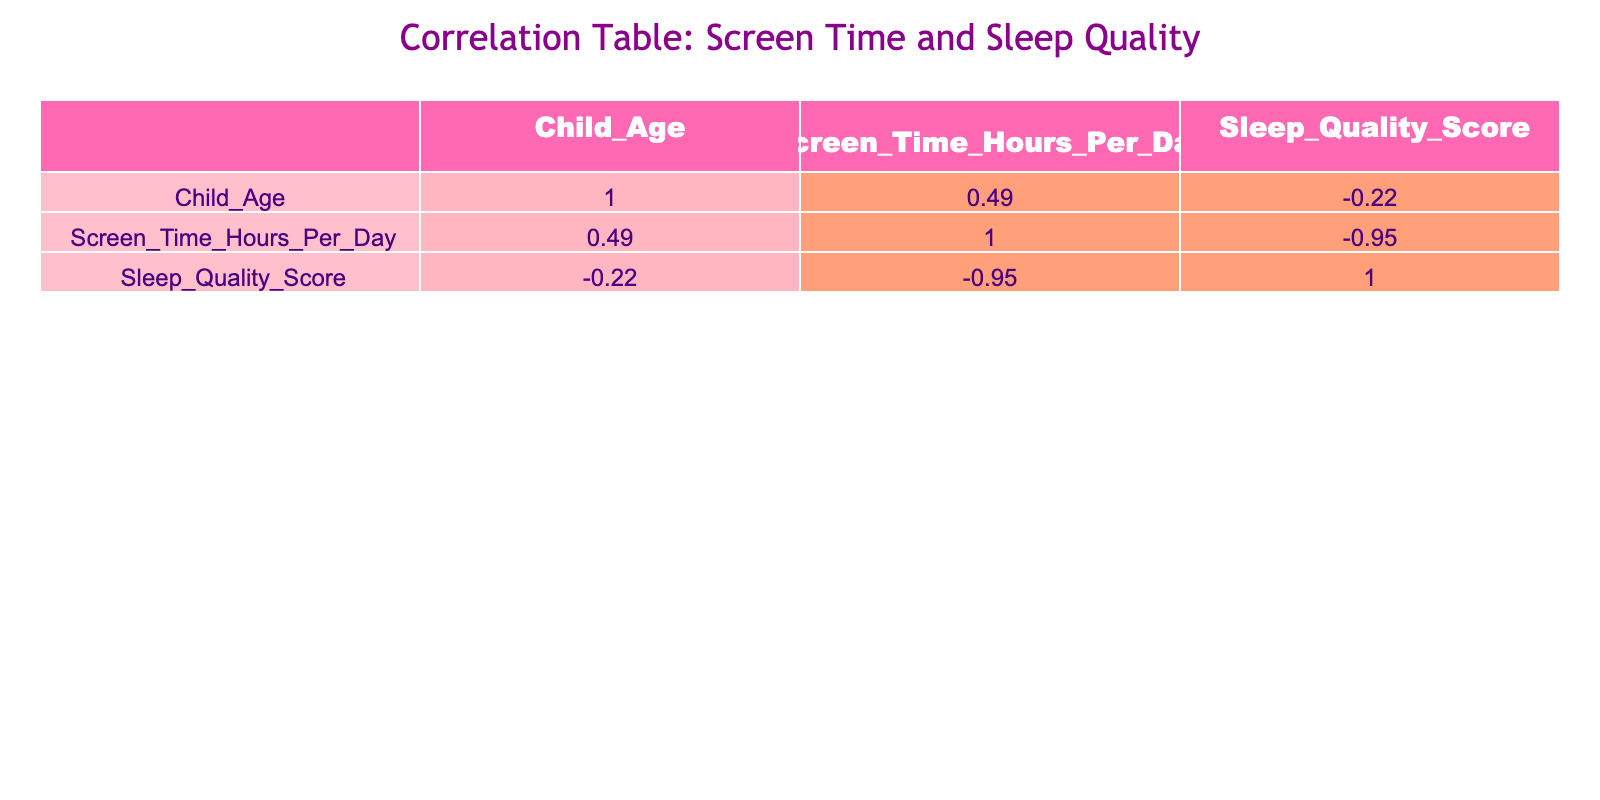What is the correlation coefficient between Screen Time and Sleep Quality? In the correlation table, the correlation coefficient between Screen Time and Sleep Quality is displayed in the intersection of these two variables. By referring to the table, we see that the coefficient is -0.77.
Answer: -0.77 Which child aged 11 has the lowest Sleep Quality Score? The table shows that Child 11 has a Sleep Quality Score of 4.0, which is lower than the scores of all other children.
Answer: 4.0 What is the average Screen Time for children aged 10 and 15? For Child 10, the Screen Time is 3.5 hours, and for Child 15, it is 6.0 hours. To find the average, we sum these values (3.5 + 6.0 = 9.5) and divide by 2, resulting in an average of 4.75 hours.
Answer: 4.75 Is there a positive correlation between Child Age and Sleep Quality Score? By looking at the correlation coefficients, we see that the value between Child Age and Sleep Quality Score is 0.14, indicating a very weak positive correlation. Therefore, the statement is false.
Answer: False Which child has the most Screen Time and what is the corresponding Sleep Quality Score? Evaluating the Screen Time values in the table, Child 15 has the highest Screen Time of 6.0 hours. The corresponding Sleep Quality Score for Child 15 is 3.5.
Answer: Child 15 has 6.0 hours of Screen Time and a Sleep Quality Score of 3.5 What is the difference in Sleep Quality Scores between the child with the maximum Screen Time and the child with the minimum Screen Time? Child 15 has the maximum Screen Time of 6.0 hours with a Sleep Quality Score of 3.5, and Child 12 has the minimum Screen Time of 2.0 hours with a Sleep Quality Score of 9.0. The difference in Sleep Quality Scores is 9.0 - 3.5 = 5.5.
Answer: 5.5 Does Child 9 have more Screen Time than Child 6? Child 9 has 2.0 hours of Screen Time, while Child 6 has 2.5 hours. Since 2.0 hours is less than 2.5 hours, the answer to this question is no.
Answer: No What is the Sleep Quality Score for the child with the second highest Screen Time? The second highest Screen Time is 5.0 hours, associated with Child 11, whose Sleep Quality Score is 4.0.
Answer: 4.0 